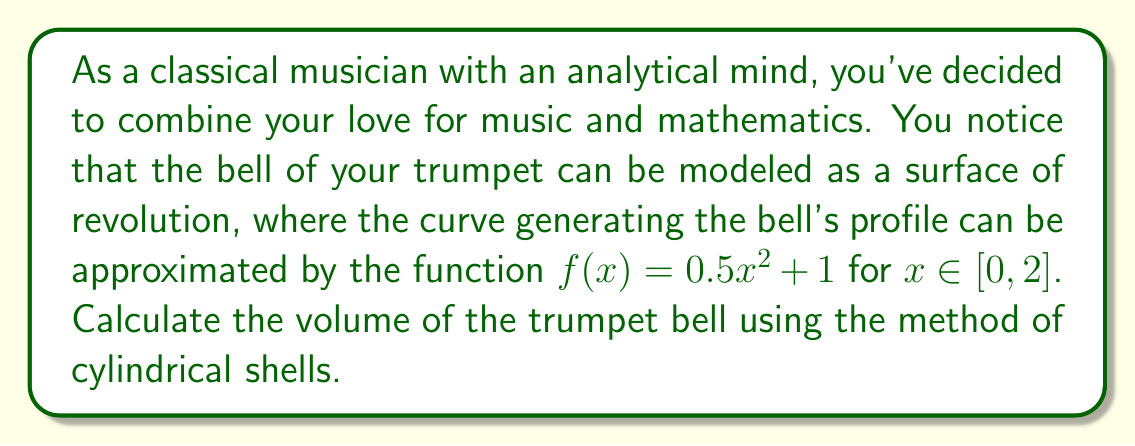Give your solution to this math problem. Let's approach this step-by-step:

1) The method of cylindrical shells for volume involves integrating $2\pi x f(x)$ over the given interval. Our integral will be:

   $$V = 2\pi \int_0^2 x f(x) dx$$

2) Substitute $f(x) = 0.5x^2 + 1$:

   $$V = 2\pi \int_0^2 x(0.5x^2 + 1) dx$$

3) Expand the integrand:

   $$V = 2\pi \int_0^2 (0.5x^3 + x) dx$$

4) Integrate term by term:

   $$V = 2\pi \left[\frac{0.5x^4}{4} + \frac{x^2}{2}\right]_0^2$$

5) Evaluate the integral at the bounds:

   $$V = 2\pi \left[(\frac{0.5 \cdot 16}{4} + \frac{4}{2}) - (0 + 0)\right]$$

6) Simplify:

   $$V = 2\pi (2 + 2) = 8\pi$$

7) Therefore, the volume of the trumpet bell is $8\pi$ cubic units.

[asy]
import graph;
size(200,200);
real f(real x) {return 0.5*x^2 + 1;}
path p = graph(f,0,2);
path axis = (0,0)--(2,0);
draw(p,blue);
draw(axis,black);
draw(reflect(O,N)*p,blue);
label("x",(-0.1,0),SW);
label("y",(0,-0.1),SE);
label("f(x)",(2,f(2)),E);
[/asy]
Answer: $8\pi$ cubic units 